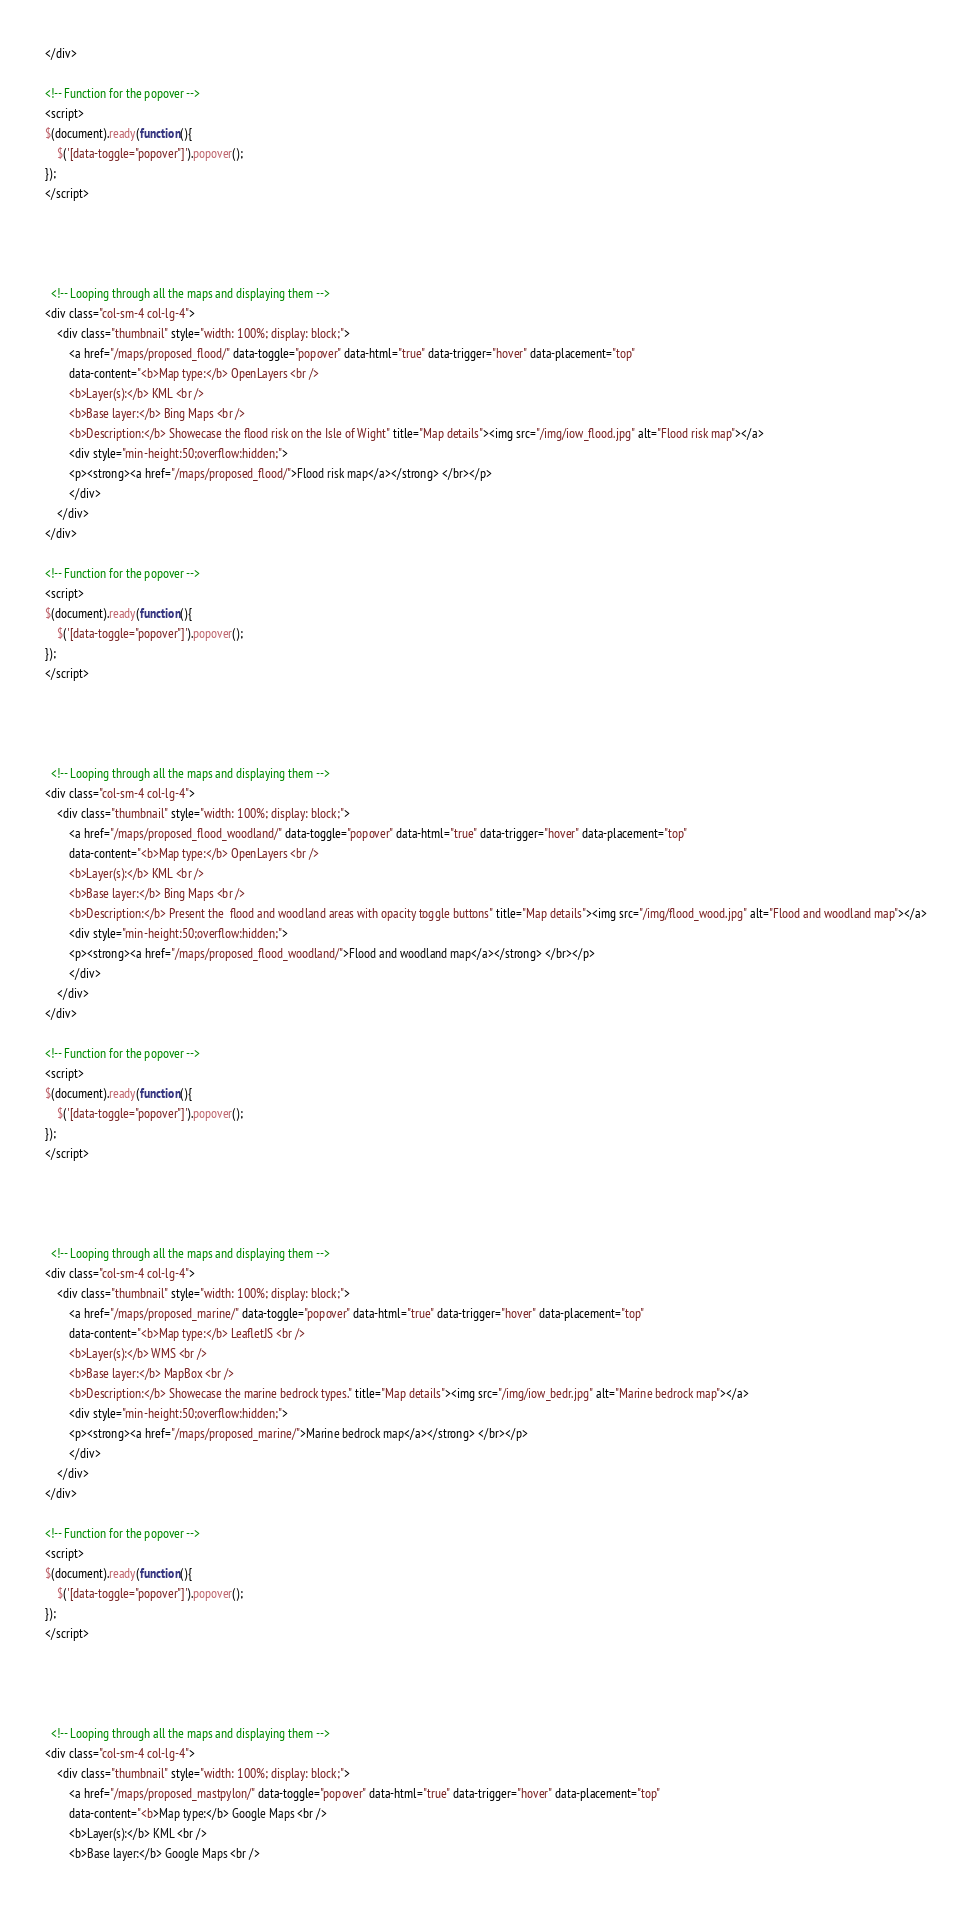<code> <loc_0><loc_0><loc_500><loc_500><_HTML_></div>

<!-- Function for the popover -->
<script>
$(document).ready(function(){
    $('[data-toggle="popover"]').popover();
});
</script>




  <!-- Looping through all the maps and displaying them -->
<div class="col-sm-4 col-lg-4">
    <div class="thumbnail" style="width: 100%; display: block;">
        <a href="/maps/proposed_flood/" data-toggle="popover" data-html="true" data-trigger="hover" data-placement="top"
        data-content="<b>Map type:</b> OpenLayers <br />
        <b>Layer(s):</b> KML <br />
        <b>Base layer:</b> Bing Maps <br />
        <b>Description:</b> Showecase the flood risk on the Isle of Wight" title="Map details"><img src="/img/iow_flood.jpg" alt="Flood risk map"></a>
        <div style="min-height:50;overflow:hidden;">
        <p><strong><a href="/maps/proposed_flood/">Flood risk map</a></strong> </br></p>
        </div>
    </div>
</div>

<!-- Function for the popover -->
<script>
$(document).ready(function(){
    $('[data-toggle="popover"]').popover();
});
</script>




  <!-- Looping through all the maps and displaying them -->
<div class="col-sm-4 col-lg-4">
    <div class="thumbnail" style="width: 100%; display: block;">
        <a href="/maps/proposed_flood_woodland/" data-toggle="popover" data-html="true" data-trigger="hover" data-placement="top"
        data-content="<b>Map type:</b> OpenLayers <br />
        <b>Layer(s):</b> KML <br />
        <b>Base layer:</b> Bing Maps <br />
        <b>Description:</b> Present the  flood and woodland areas with opacity toggle buttons" title="Map details"><img src="/img/flood_wood.jpg" alt="Flood and woodland map"></a>
        <div style="min-height:50;overflow:hidden;">
        <p><strong><a href="/maps/proposed_flood_woodland/">Flood and woodland map</a></strong> </br></p>
        </div>
    </div>
</div>

<!-- Function for the popover -->
<script>
$(document).ready(function(){
    $('[data-toggle="popover"]').popover();
});
</script>




  <!-- Looping through all the maps and displaying them -->
<div class="col-sm-4 col-lg-4">
    <div class="thumbnail" style="width: 100%; display: block;">
        <a href="/maps/proposed_marine/" data-toggle="popover" data-html="true" data-trigger="hover" data-placement="top"
        data-content="<b>Map type:</b> LeafletJS <br />
        <b>Layer(s):</b> WMS <br />
        <b>Base layer:</b> MapBox <br />
        <b>Description:</b> Showecase the marine bedrock types." title="Map details"><img src="/img/iow_bedr.jpg" alt="Marine bedrock map"></a>
        <div style="min-height:50;overflow:hidden;">
        <p><strong><a href="/maps/proposed_marine/">Marine bedrock map</a></strong> </br></p>
        </div>
    </div>
</div>

<!-- Function for the popover -->
<script>
$(document).ready(function(){
    $('[data-toggle="popover"]').popover();
});
</script>




  <!-- Looping through all the maps and displaying them -->
<div class="col-sm-4 col-lg-4">
    <div class="thumbnail" style="width: 100%; display: block;">
        <a href="/maps/proposed_mastpylon/" data-toggle="popover" data-html="true" data-trigger="hover" data-placement="top"
        data-content="<b>Map type:</b> Google Maps <br />
        <b>Layer(s):</b> KML <br />
        <b>Base layer:</b> Google Maps <br /></code> 